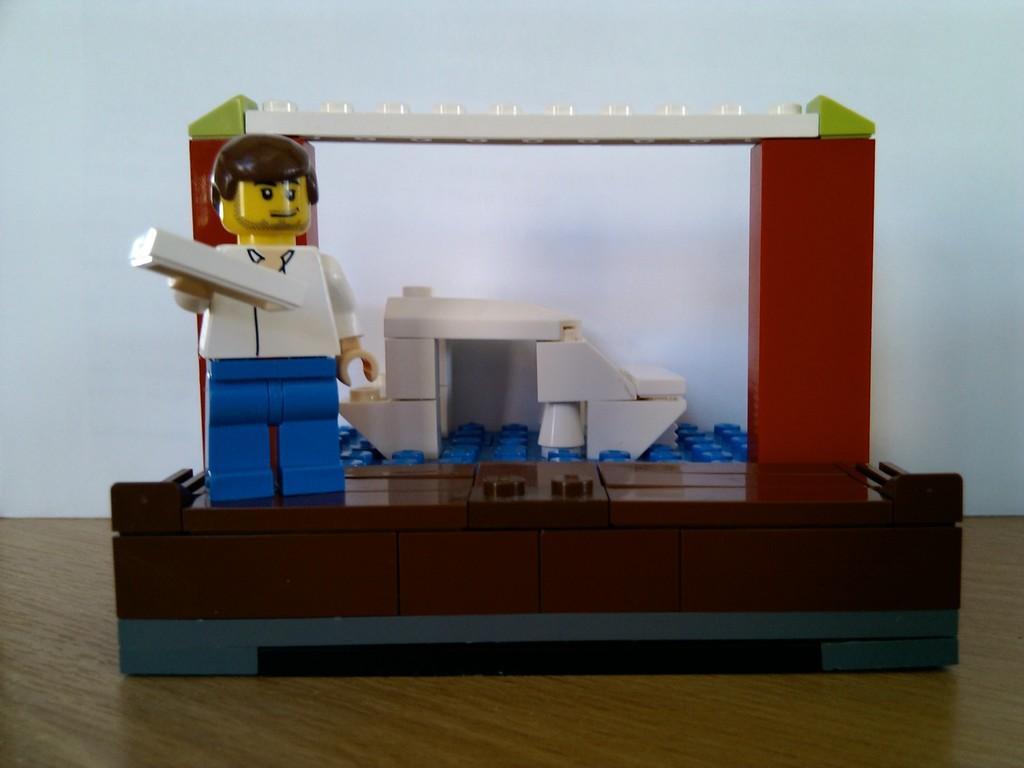Can you describe this image briefly? In the left it is in the shape of a man, behind this it's a wall. 